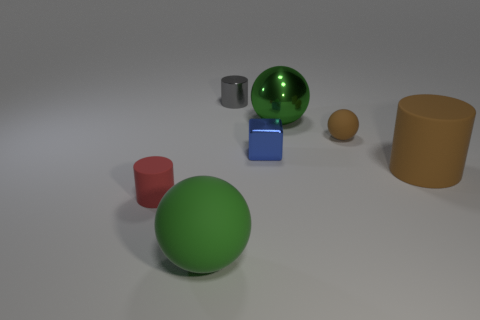There is a big matte thing right of the tiny blue object; what is its shape?
Offer a terse response. Cylinder. Is the size of the gray shiny thing the same as the rubber cylinder that is on the left side of the tiny block?
Offer a terse response. Yes. Is there a block made of the same material as the brown cylinder?
Provide a short and direct response. No. What number of cylinders are red things or small metallic things?
Your answer should be compact. 2. There is a tiny matte cylinder in front of the large metallic sphere; are there any tiny blue metallic blocks that are to the left of it?
Your answer should be compact. No. Is the number of metal things less than the number of big metal balls?
Your response must be concise. No. What number of matte things have the same shape as the tiny gray metallic object?
Give a very brief answer. 2. What number of blue objects are either tiny objects or large matte spheres?
Your response must be concise. 1. How big is the brown rubber object behind the matte cylinder behind the small red object?
Keep it short and to the point. Small. There is another large object that is the same shape as the green matte thing; what is its material?
Make the answer very short. Metal. 